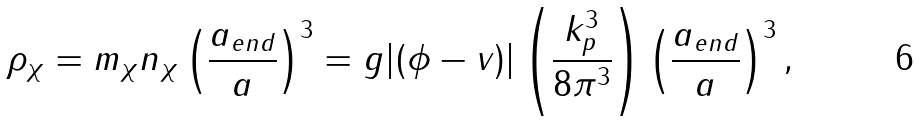Convert formula to latex. <formula><loc_0><loc_0><loc_500><loc_500>\rho _ { \chi } = m _ { \chi } n _ { \chi } \left ( \frac { a _ { e n d } } { a } \right ) ^ { 3 } = g | ( \phi - v ) | \left ( \frac { k _ { p } ^ { 3 } } { 8 \pi ^ { 3 } } \right ) \left ( \frac { a _ { e n d } } { a } \right ) ^ { 3 } ,</formula> 